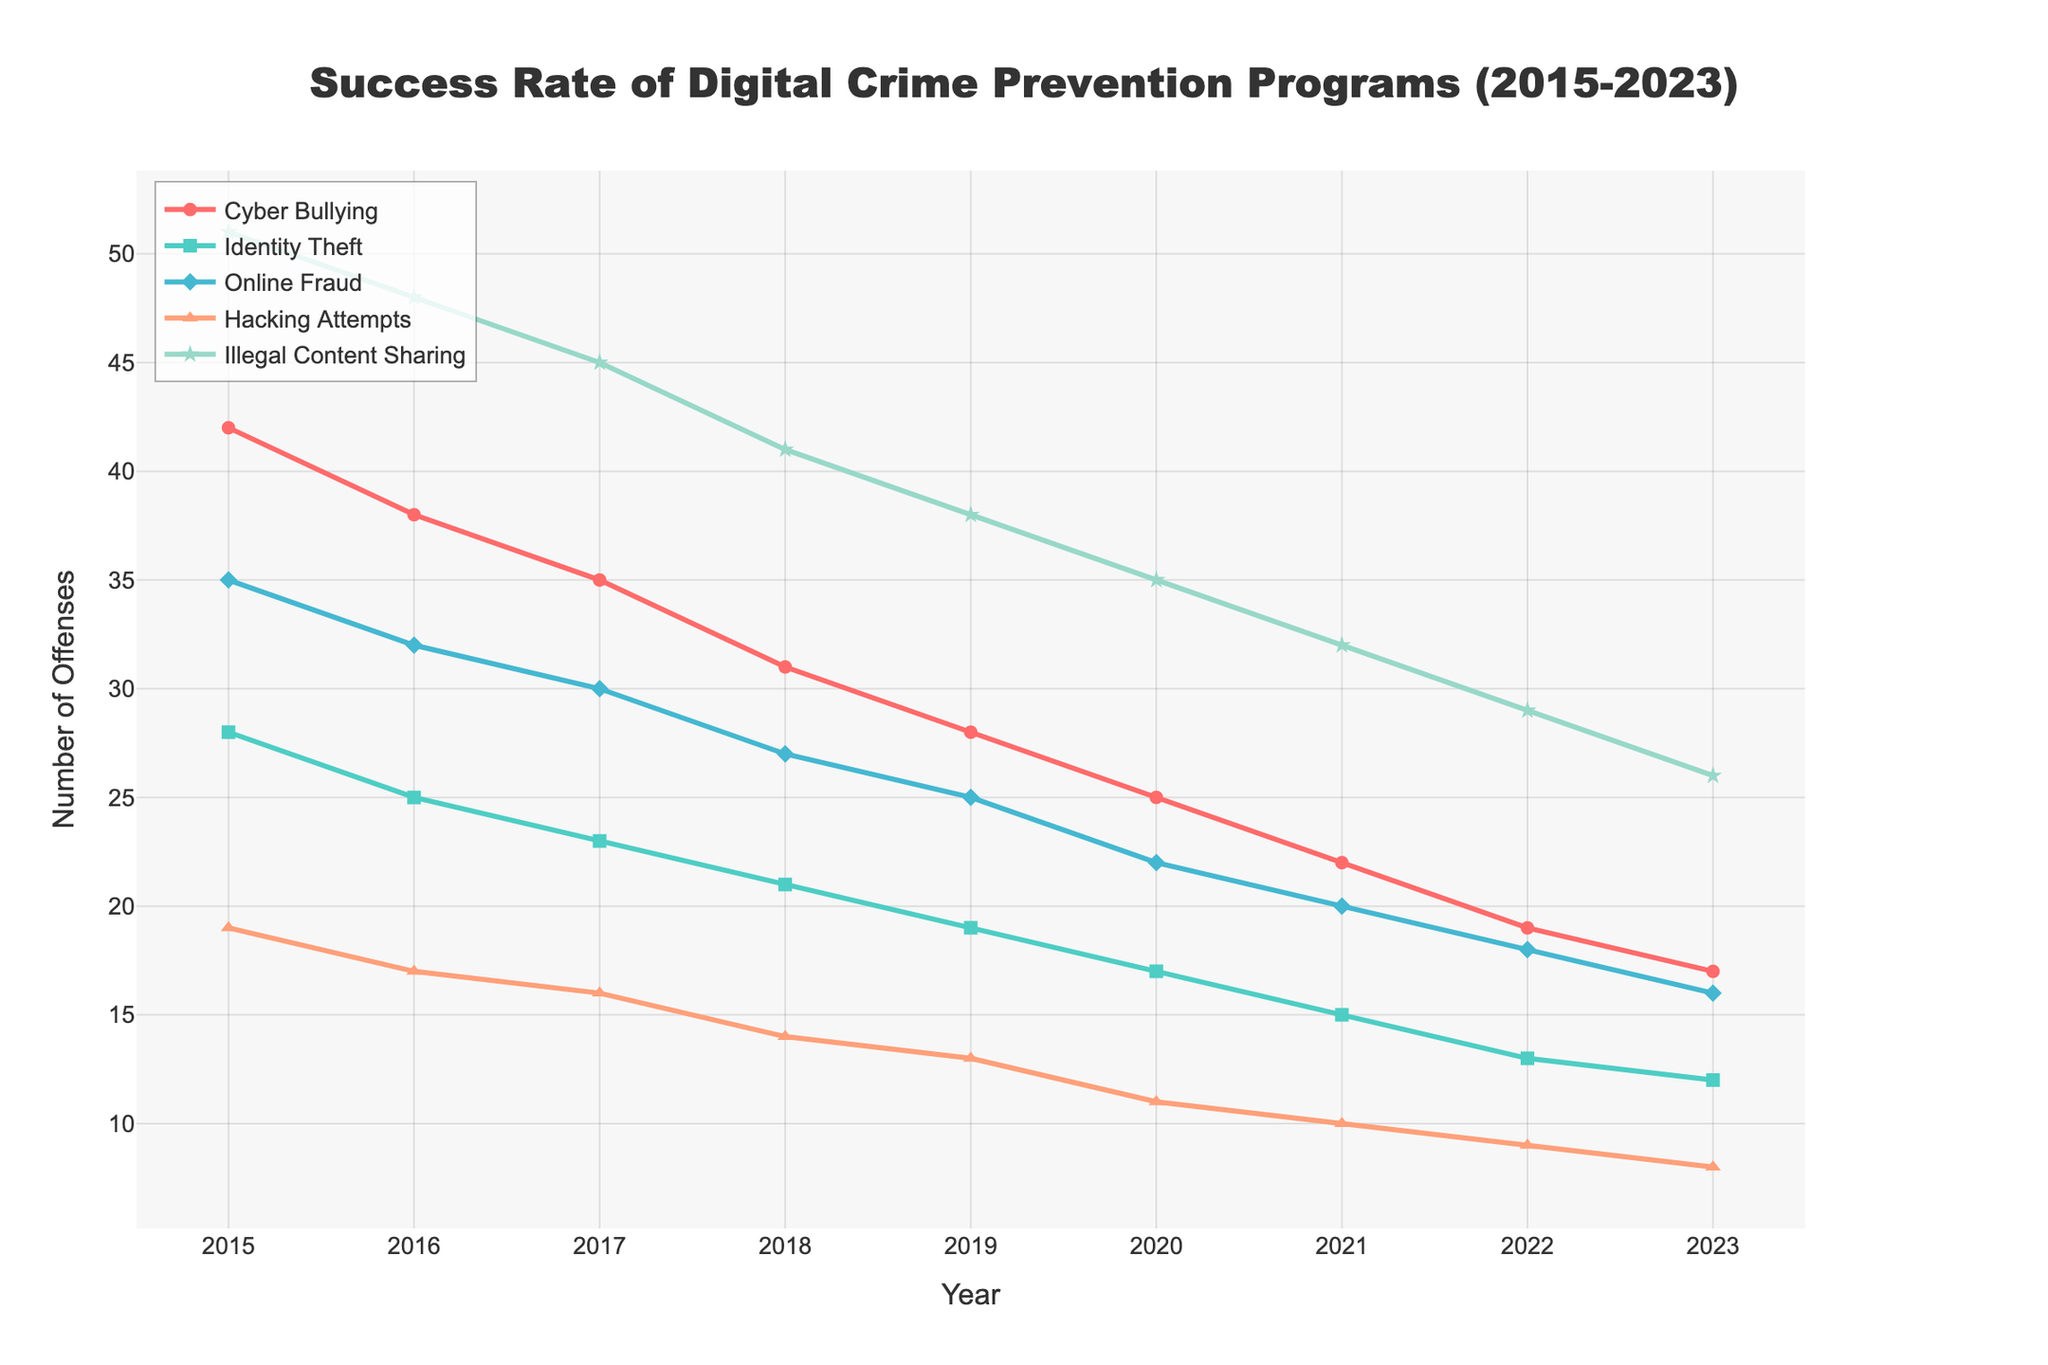What is the trend in cyberbullying incidents from 2015 to 2023? The line representing cyberbullying shows a consistent downward trend from 42 incidents in 2015 to 17 incidents in 2023. This indicates that cyberbullying incidents have steadily decreased over the years.
Answer: Decreasing Which type of offense had the highest number of incidents in 2015? The highest point on the y-axis in 2015 is for Illegal Content Sharing, with 51 incidents.
Answer: Illegal Content Sharing By how much did identity theft incidents reduce from 2015 to 2023? In 2015, there were 28 incidents of identity theft, and in 2023, there were 12 incidents. The reduction can be calculated as 28 - 12 = 16.
Answer: 16 Between cyberbullying and hacking attempts, which had a more significant reduction in incidents from 2015 to 2023 and by how much? Cyberbullying incidents reduced from 42 to 17 (a reduction of 25), whereas hacking attempts reduced from 19 to 8 (a reduction of 11). Therefore, cyberbullying had a more significant reduction of 25 incidents.
Answer: Cyberbullying by 25 What is the average number of online fraud incidents from 2015 to 2023? The number of online fraud incidents for each year are: 35, 32, 30, 27, 25, 22, 20, 18, 16 respectively. Adding them gives 225, and dividing by 9 (the number of years) results in an average of 25.
Answer: 25 In what year did hacking attempts have the same number of incidents as illegal content sharing had in 2021? Illegal Content Sharing had 32 incidents in 2021. Looking at the plot, Hacking Attempts never reached exactly 32 incidents in any year. Therefore, no such year exists.
Answer: No such year Which offense type saw the least reduction in incidents based on the chart? Illegal Content Sharing saw a reduction from 51 incidents in 2015 to 26 incidents in 2023, a decrease of 25 incidents. Comparing the reductions: Cyber Bullying (25), Identity Theft (16), Online Fraud (19), Hacking Attempts (11), Illegal Content Sharing (25). The least reduction occurred in Hacking Attempts (11).
Answer: Hacking Attempts What is the difference in the number of incidents of illegal content sharing between 2016 and 2018? Illegal Content Sharing incidents in 2016 were 48, and in 2018 they were 41. The difference can be calculated as 48 - 41 = 7.
Answer: 7 Which offense type had the most uniform decrease over the years? Cyber Bullying had a consistent and uniform decrease every year from 42 incidents in 2015 to 17 incidents in 2023, unlike other types which had some fluctuations or changes in their rate of decrease.
Answer: Cyber Bullying How did the number of identity theft offenses change from 2018 to 2020? In 2018, there were 21 incidents of identity theft, and in 2020, there were 17 incidents. The change can be calculated as 21 - 17 = 4, indicating a reduction.
Answer: Reduced by 4 